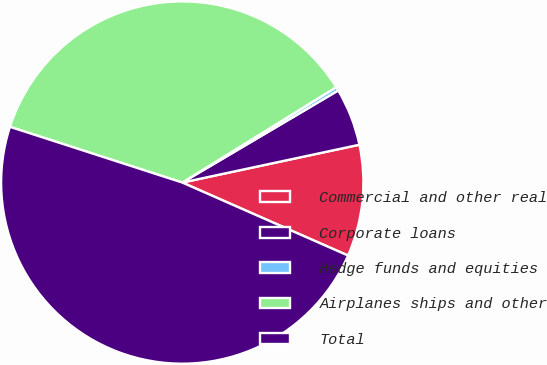<chart> <loc_0><loc_0><loc_500><loc_500><pie_chart><fcel>Commercial and other real<fcel>Corporate loans<fcel>Hedge funds and equities<fcel>Airplanes ships and other<fcel>Total<nl><fcel>9.95%<fcel>5.14%<fcel>0.34%<fcel>36.19%<fcel>48.37%<nl></chart> 